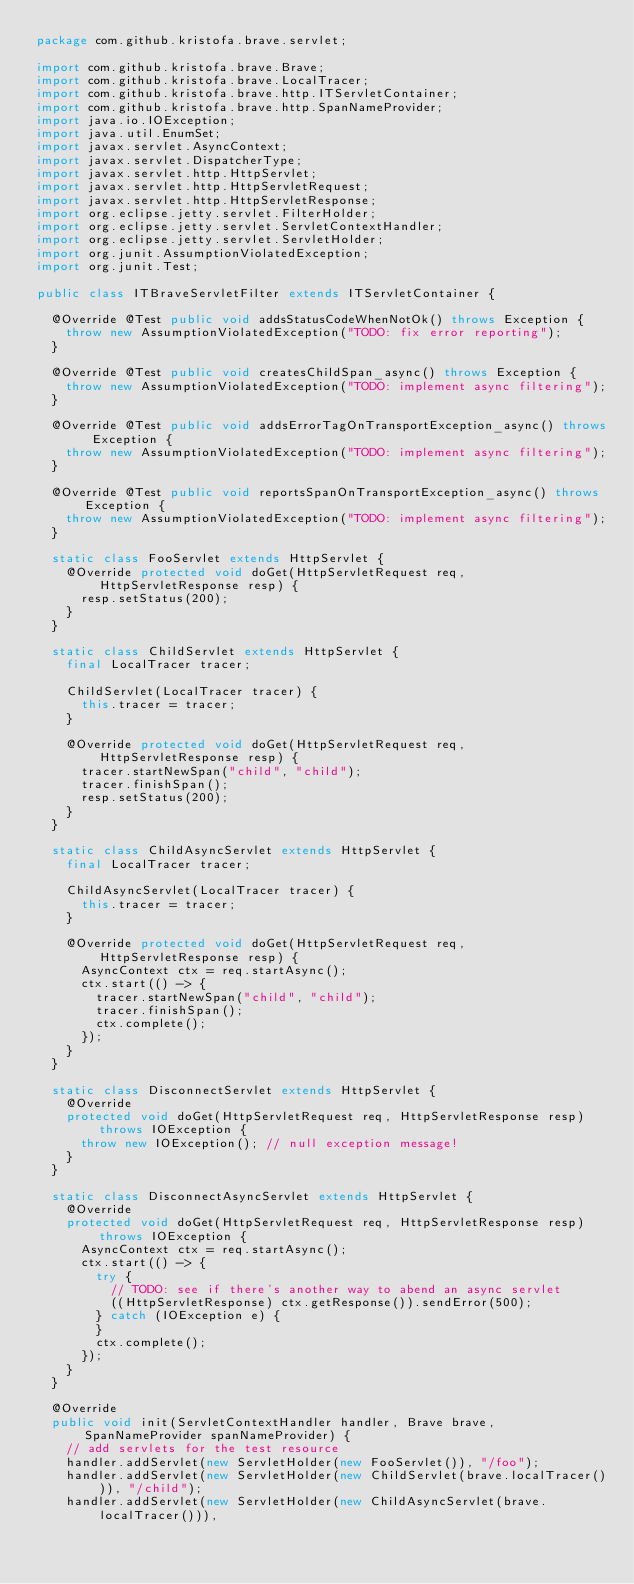<code> <loc_0><loc_0><loc_500><loc_500><_Java_>package com.github.kristofa.brave.servlet;

import com.github.kristofa.brave.Brave;
import com.github.kristofa.brave.LocalTracer;
import com.github.kristofa.brave.http.ITServletContainer;
import com.github.kristofa.brave.http.SpanNameProvider;
import java.io.IOException;
import java.util.EnumSet;
import javax.servlet.AsyncContext;
import javax.servlet.DispatcherType;
import javax.servlet.http.HttpServlet;
import javax.servlet.http.HttpServletRequest;
import javax.servlet.http.HttpServletResponse;
import org.eclipse.jetty.servlet.FilterHolder;
import org.eclipse.jetty.servlet.ServletContextHandler;
import org.eclipse.jetty.servlet.ServletHolder;
import org.junit.AssumptionViolatedException;
import org.junit.Test;

public class ITBraveServletFilter extends ITServletContainer {

  @Override @Test public void addsStatusCodeWhenNotOk() throws Exception {
    throw new AssumptionViolatedException("TODO: fix error reporting");
  }

  @Override @Test public void createsChildSpan_async() throws Exception {
    throw new AssumptionViolatedException("TODO: implement async filtering");
  }

  @Override @Test public void addsErrorTagOnTransportException_async() throws Exception {
    throw new AssumptionViolatedException("TODO: implement async filtering");
  }

  @Override @Test public void reportsSpanOnTransportException_async() throws Exception {
    throw new AssumptionViolatedException("TODO: implement async filtering");
  }

  static class FooServlet extends HttpServlet {
    @Override protected void doGet(HttpServletRequest req, HttpServletResponse resp) {
      resp.setStatus(200);
    }
  }

  static class ChildServlet extends HttpServlet {
    final LocalTracer tracer;

    ChildServlet(LocalTracer tracer) {
      this.tracer = tracer;
    }

    @Override protected void doGet(HttpServletRequest req, HttpServletResponse resp) {
      tracer.startNewSpan("child", "child");
      tracer.finishSpan();
      resp.setStatus(200);
    }
  }

  static class ChildAsyncServlet extends HttpServlet {
    final LocalTracer tracer;

    ChildAsyncServlet(LocalTracer tracer) {
      this.tracer = tracer;
    }

    @Override protected void doGet(HttpServletRequest req, HttpServletResponse resp) {
      AsyncContext ctx = req.startAsync();
      ctx.start(() -> {
        tracer.startNewSpan("child", "child");
        tracer.finishSpan();
        ctx.complete();
      });
    }
  }

  static class DisconnectServlet extends HttpServlet {
    @Override
    protected void doGet(HttpServletRequest req, HttpServletResponse resp) throws IOException {
      throw new IOException(); // null exception message!
    }
  }

  static class DisconnectAsyncServlet extends HttpServlet {
    @Override
    protected void doGet(HttpServletRequest req, HttpServletResponse resp) throws IOException {
      AsyncContext ctx = req.startAsync();
      ctx.start(() -> {
        try {
          // TODO: see if there's another way to abend an async servlet
          ((HttpServletResponse) ctx.getResponse()).sendError(500);
        } catch (IOException e) {
        }
        ctx.complete();
      });
    }
  }

  @Override
  public void init(ServletContextHandler handler, Brave brave, SpanNameProvider spanNameProvider) {
    // add servlets for the test resource
    handler.addServlet(new ServletHolder(new FooServlet()), "/foo");
    handler.addServlet(new ServletHolder(new ChildServlet(brave.localTracer())), "/child");
    handler.addServlet(new ServletHolder(new ChildAsyncServlet(brave.localTracer())),</code> 